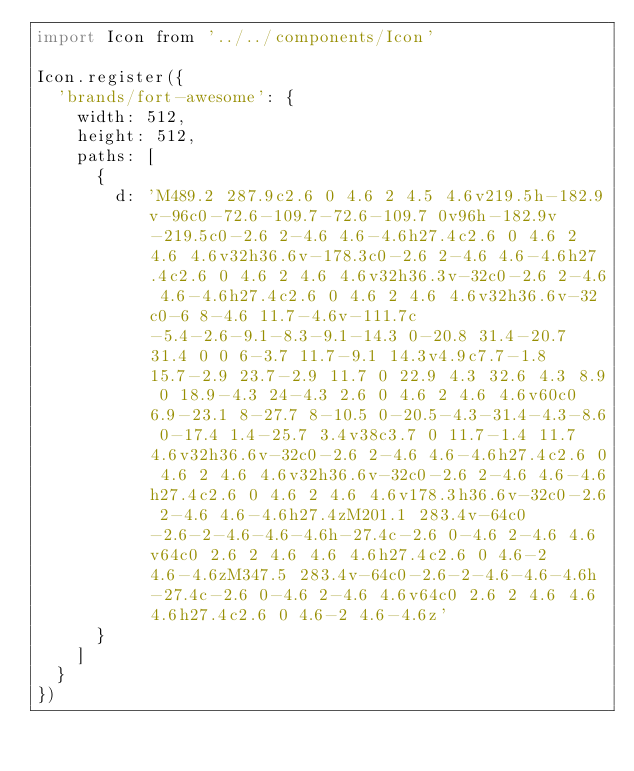<code> <loc_0><loc_0><loc_500><loc_500><_JavaScript_>import Icon from '../../components/Icon'

Icon.register({
  'brands/fort-awesome': {
    width: 512,
    height: 512,
    paths: [
      {
        d: 'M489.2 287.9c2.6 0 4.6 2 4.5 4.6v219.5h-182.9v-96c0-72.6-109.7-72.6-109.7 0v96h-182.9v-219.5c0-2.6 2-4.6 4.6-4.6h27.4c2.6 0 4.6 2 4.6 4.6v32h36.6v-178.3c0-2.6 2-4.6 4.6-4.6h27.4c2.6 0 4.6 2 4.6 4.6v32h36.3v-32c0-2.6 2-4.6 4.6-4.6h27.4c2.6 0 4.6 2 4.6 4.6v32h36.6v-32c0-6 8-4.6 11.7-4.6v-111.7c-5.4-2.6-9.1-8.3-9.1-14.3 0-20.8 31.4-20.7 31.4 0 0 6-3.7 11.7-9.1 14.3v4.9c7.7-1.8 15.7-2.9 23.7-2.9 11.7 0 22.9 4.3 32.6 4.3 8.9 0 18.9-4.3 24-4.3 2.6 0 4.6 2 4.6 4.6v60c0 6.9-23.1 8-27.7 8-10.5 0-20.5-4.3-31.4-4.3-8.6 0-17.4 1.4-25.7 3.4v38c3.7 0 11.7-1.4 11.7 4.6v32h36.6v-32c0-2.6 2-4.6 4.6-4.6h27.4c2.6 0 4.6 2 4.6 4.6v32h36.6v-32c0-2.6 2-4.6 4.6-4.6h27.4c2.6 0 4.6 2 4.6 4.6v178.3h36.6v-32c0-2.6 2-4.6 4.6-4.6h27.4zM201.1 283.4v-64c0-2.6-2-4.6-4.6-4.6h-27.4c-2.6 0-4.6 2-4.6 4.6v64c0 2.6 2 4.6 4.6 4.6h27.4c2.6 0 4.6-2 4.6-4.6zM347.5 283.4v-64c0-2.6-2-4.6-4.6-4.6h-27.4c-2.6 0-4.6 2-4.6 4.6v64c0 2.6 2 4.6 4.6 4.6h27.4c2.6 0 4.6-2 4.6-4.6z'
      }
    ]
  }
})
</code> 